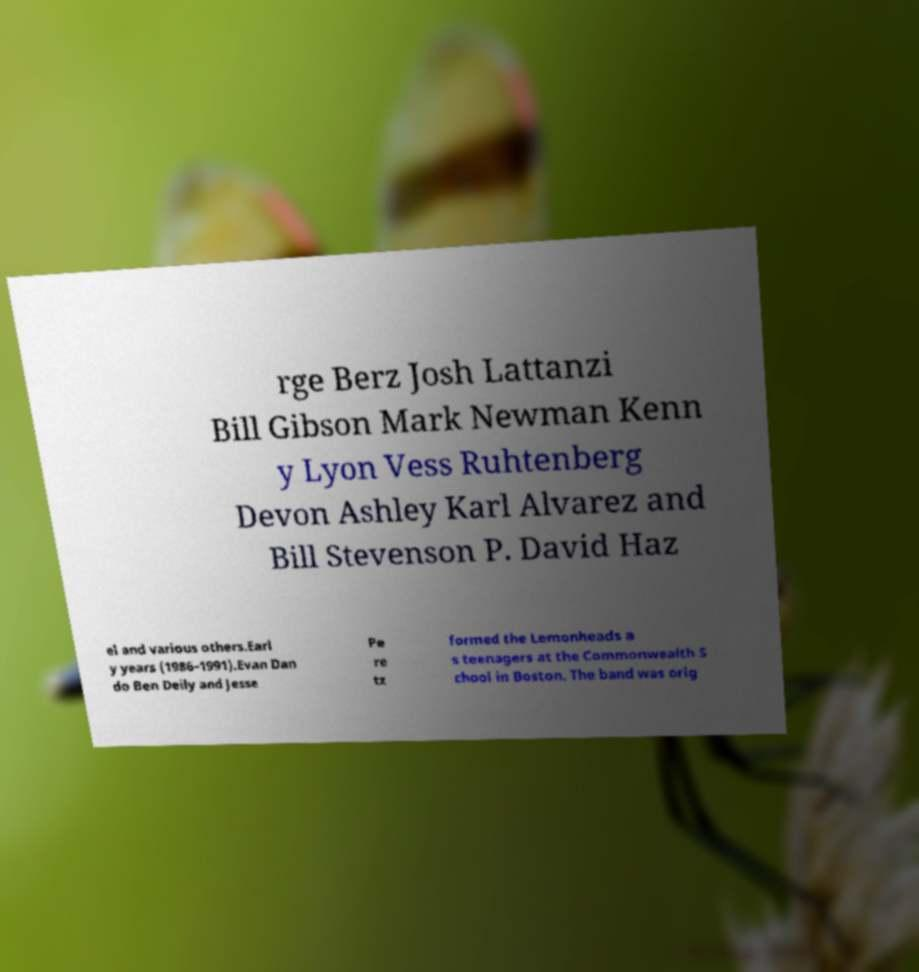Please read and relay the text visible in this image. What does it say? rge Berz Josh Lattanzi Bill Gibson Mark Newman Kenn y Lyon Vess Ruhtenberg Devon Ashley Karl Alvarez and Bill Stevenson P. David Haz el and various others.Earl y years (1986–1991).Evan Dan do Ben Deily and Jesse Pe re tz formed the Lemonheads a s teenagers at the Commonwealth S chool in Boston. The band was orig 